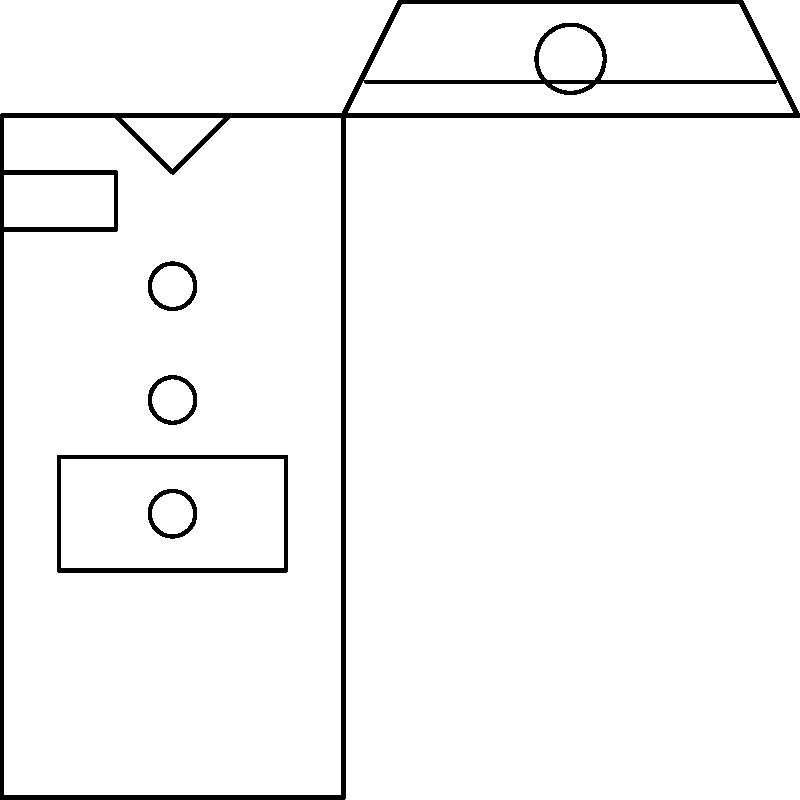Based on the visual details of this military uniform, which era does it most likely represent? To determine the era of this military uniform, let's analyze its key features:

1. Overall design: The uniform shows a simple, streamlined design typical of mid-20th century military attire.

2. Collar: The uniform features a stand-up collar, which was common in military uniforms from the late 19th to mid-20th centuries.

3. Epaulettes: The presence of epaulettes (shoulder boards) suggests a formal or dress uniform, common in many eras but particularly prominent in the 20th century.

4. Pocket placement: The single breast pocket is positioned relatively high, which is characteristic of military uniforms from the 1940s and 1950s.

5. Button arrangement: The three-button front closure was typical of military jackets from the World War II era and immediately after.

6. Hat design: The cap shown has a low, flat top with a short visor, resembling the "crusher" or "overseas" caps used by American forces during World War II and the Korean War.

7. Hat emblem: The circular emblem on the hat is consistent with the cap devices used on American military headgear during the mid-20th century.

Considering these elements together, the uniform most closely resembles those used by Western (particularly American) military forces during the 1940s to early 1950s period, encompassing World War II and the Korean War era.
Answer: 1940s-1950s (World War II/Korean War era) 